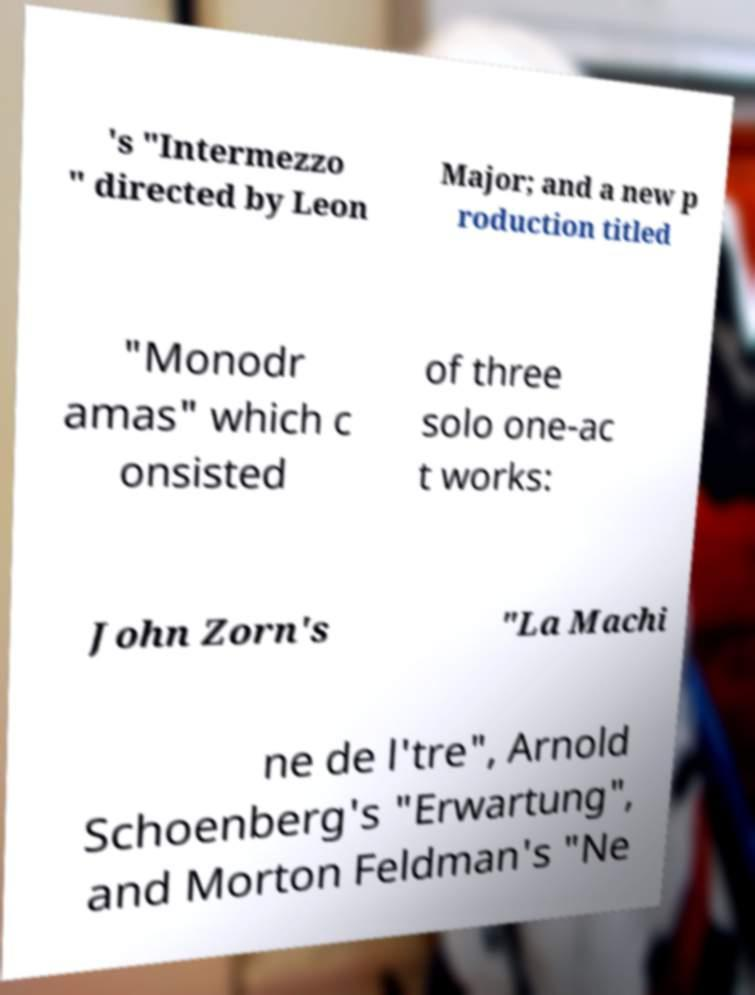Could you extract and type out the text from this image? 's "Intermezzo " directed by Leon Major; and a new p roduction titled "Monodr amas" which c onsisted of three solo one-ac t works: John Zorn's "La Machi ne de l'tre", Arnold Schoenberg's "Erwartung", and Morton Feldman's "Ne 